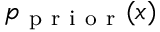<formula> <loc_0><loc_0><loc_500><loc_500>p _ { p r i o r } ( x )</formula> 